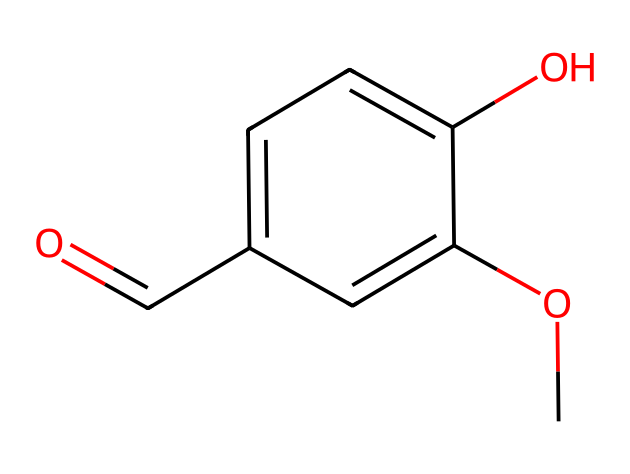What is the functional group present in vanillin? The structure shows a carbonyl group (C=O) attached to a carbon atom, which is characteristic of aldehydes. This functional group is responsible for its classification.
Answer: carbonyl group How many carbon atoms are in the vanillin molecule? Counting the carbon atoms visible in the SMILES representation, there are eight carbon atoms present in total.
Answer: eight What type of compound is vanillin classified as? Based on the presence of the aldehyde functional group and the phenolic compound structure, vanillin is classified as an aromatic aldehyde.
Answer: aromatic aldehyde Which group contributes to vanillin’s sweetness? The methoxy group (–OCH3) attached to the aromatic ring can enhance the sweetness of the flavor and aroma profile of vanillin.
Answer: methoxy group What is the total number of hydroxyl (–OH) groups in vanillin? Upon reviewing the structure, there is one hydroxyl group (-OH) present in the molecule, located on the aromatic ring.
Answer: one What is the significance of the aldehyde group in flavoring? The aldehyde group in vanillin contributes significantly to its distinct vanilla flavor profile, making it a key component in food flavoring, particularly in snacks and desserts.
Answer: flavor profile 